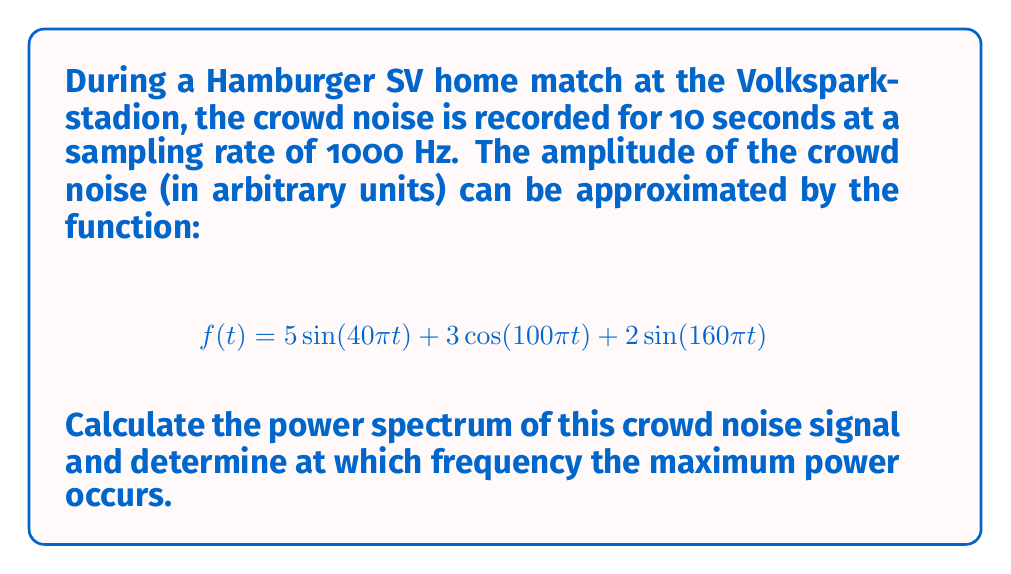What is the answer to this math problem? To calculate the power spectrum and find the frequency with maximum power, we'll follow these steps:

1) First, we need to find the Fourier Transform of $f(t)$. The Fourier Transform of $a\sin(\omega t)$ is $\frac{ai}{2}[\delta(\omega) - \delta(-\omega)]$, and for $a\cos(\omega t)$ it's $\frac{a}{2}[\delta(\omega) + \delta(-\omega)]$.

2) Therefore, the Fourier Transform $F(\omega)$ of $f(t)$ is:

   $$F(\omega) = \frac{5i}{2}[\delta(\omega-40\pi) - \delta(\omega+40\pi)] + \frac{3}{2}[\delta(\omega-100\pi) + \delta(\omega+100\pi)] + \frac{2i}{2}[\delta(\omega-160\pi) - \delta(\omega+160\pi)]$$

3) The power spectrum $S(\omega)$ is the square of the magnitude of the Fourier Transform:

   $$S(\omega) = |F(\omega)|^2$$

4) Squaring the magnitude of each term:

   At $\omega = \pm 40\pi$: $(\frac{5}{2})^2 = 6.25$
   At $\omega = \pm 100\pi$: $(\frac{3}{2})^2 = 2.25$
   At $\omega = \pm 160\pi$: $(\frac{2}{2})^2 = 1$

5) Therefore, the power spectrum is:

   $$S(\omega) = 6.25[\delta(\omega-40\pi) + \delta(\omega+40\pi)] + 2.25[\delta(\omega-100\pi) + \delta(\omega+100\pi)] + 1[\delta(\omega-160\pi) + \delta(\omega+160\pi)]$$

6) The maximum power occurs at the frequency with the largest coefficient, which is 6.25 at $\omega = \pm 40\pi$.

7) To convert angular frequency to Hz, we use $f = \frac{\omega}{2\pi}$:

   $$f = \frac{40\pi}{2\pi} = 20 \text{ Hz}$$

Thus, the maximum power occurs at 20 Hz.
Answer: 20 Hz 